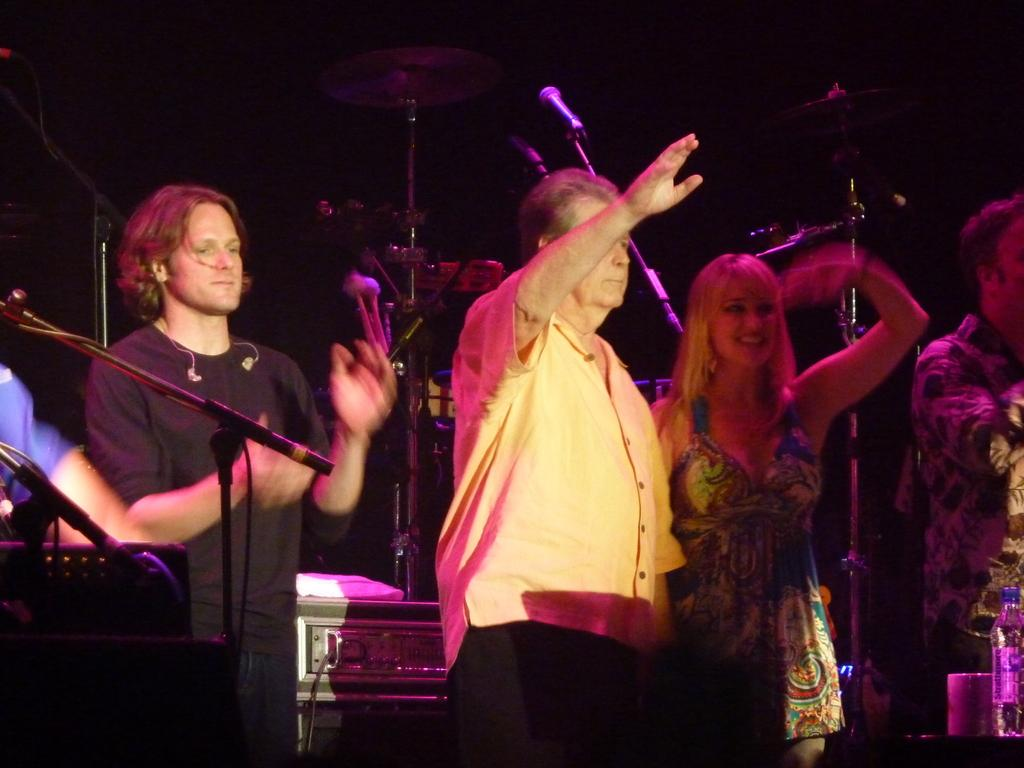What can be seen in the image involving people? There are people standing in the image. What objects are present that are typically used for amplifying sound? There are microphones (mikes) in the image. What type of instruments can be seen in the image? There are musical instruments in the image. Can you describe an object located in the bottom right corner of the image? There is a bottle in the bottom right corner of the image. What type of hat is being distributed to the people in the image? There is no hat present in the image, and no distribution is taking place. 